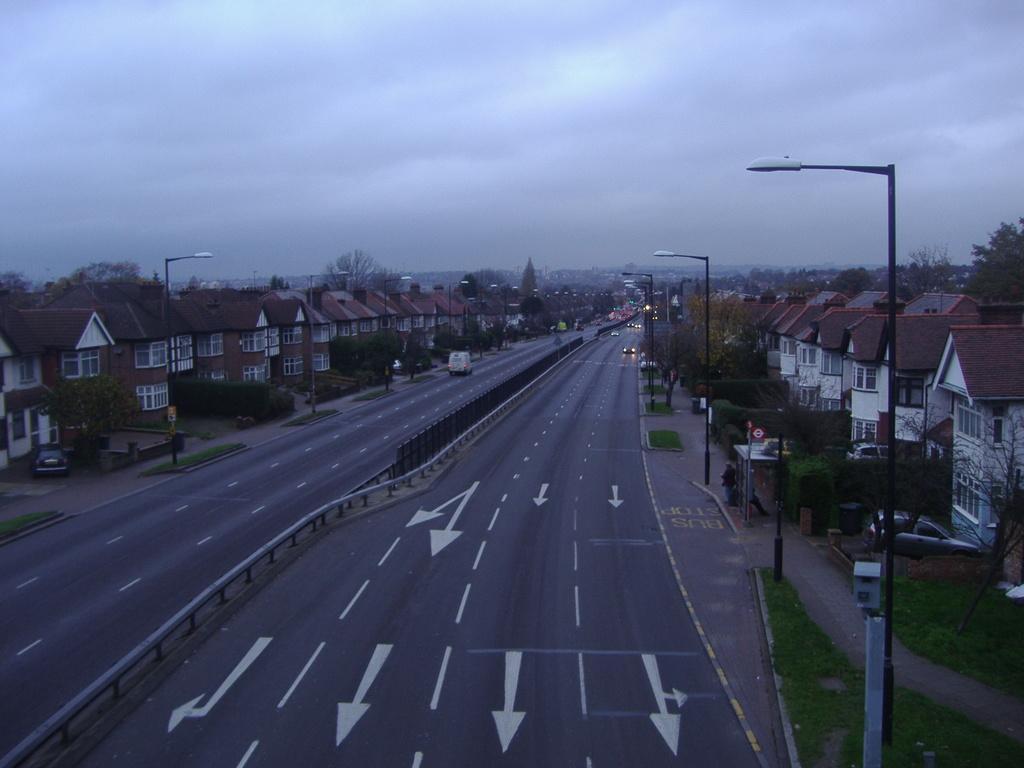How would you summarize this image in a sentence or two? At the center of the image there is a road. On the road there is some vehicles passing. On the right and left side of the image there are few buildings, in front of the buildings there are street lights. In the background there is a sky. 